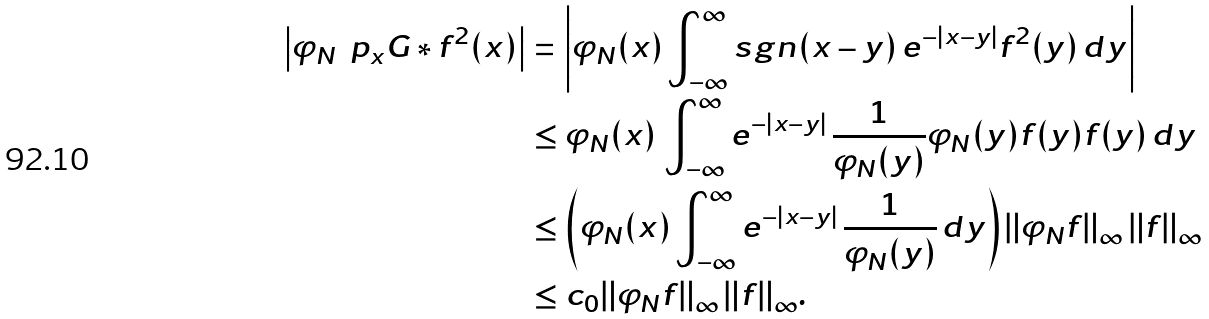<formula> <loc_0><loc_0><loc_500><loc_500>\left | \varphi _ { N } \, \ p _ { x } G \ast f ^ { 2 } ( x ) \right | & = \left | \varphi _ { N } ( x ) \int _ { - \infty } ^ { \infty } s g n ( x - y ) \, e ^ { - | x - y | } f ^ { 2 } ( y ) \, d y \right | \\ & \leq \varphi _ { N } ( x ) \, \int _ { - \infty } ^ { \infty } e ^ { - | x - y | } \, \frac { 1 } { \varphi _ { N } ( y ) } \varphi _ { N } ( y ) f ( y ) f ( y ) \, d y \\ & \leq \left ( \varphi _ { N } ( x ) \int _ { - \infty } ^ { \infty } e ^ { - | x - y | } \, \frac { 1 } { \varphi _ { N } ( y ) } \, d y \right ) \| \varphi _ { N } f \| _ { \infty } \, \| f \| _ { \infty } \\ & \leq c _ { 0 } \| \varphi _ { N } f \| _ { \infty } \, \| f \| _ { \infty } .</formula> 